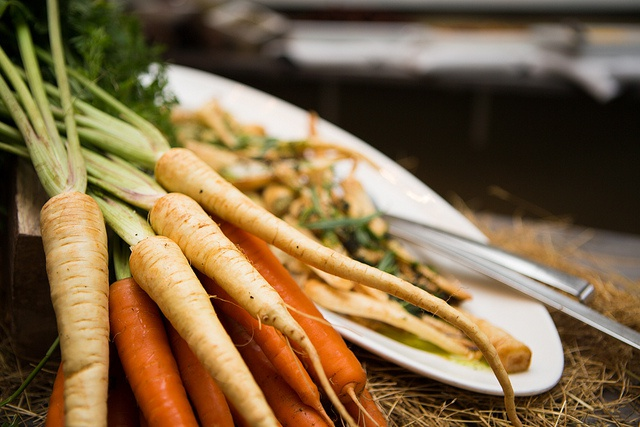Describe the objects in this image and their specific colors. I can see carrot in darkgreen, tan, and olive tones, carrot in darkgreen, tan, olive, and orange tones, carrot in darkgreen, tan, olive, and beige tones, carrot in darkgreen, tan, orange, olive, and beige tones, and carrot in darkgreen, red, and maroon tones in this image. 